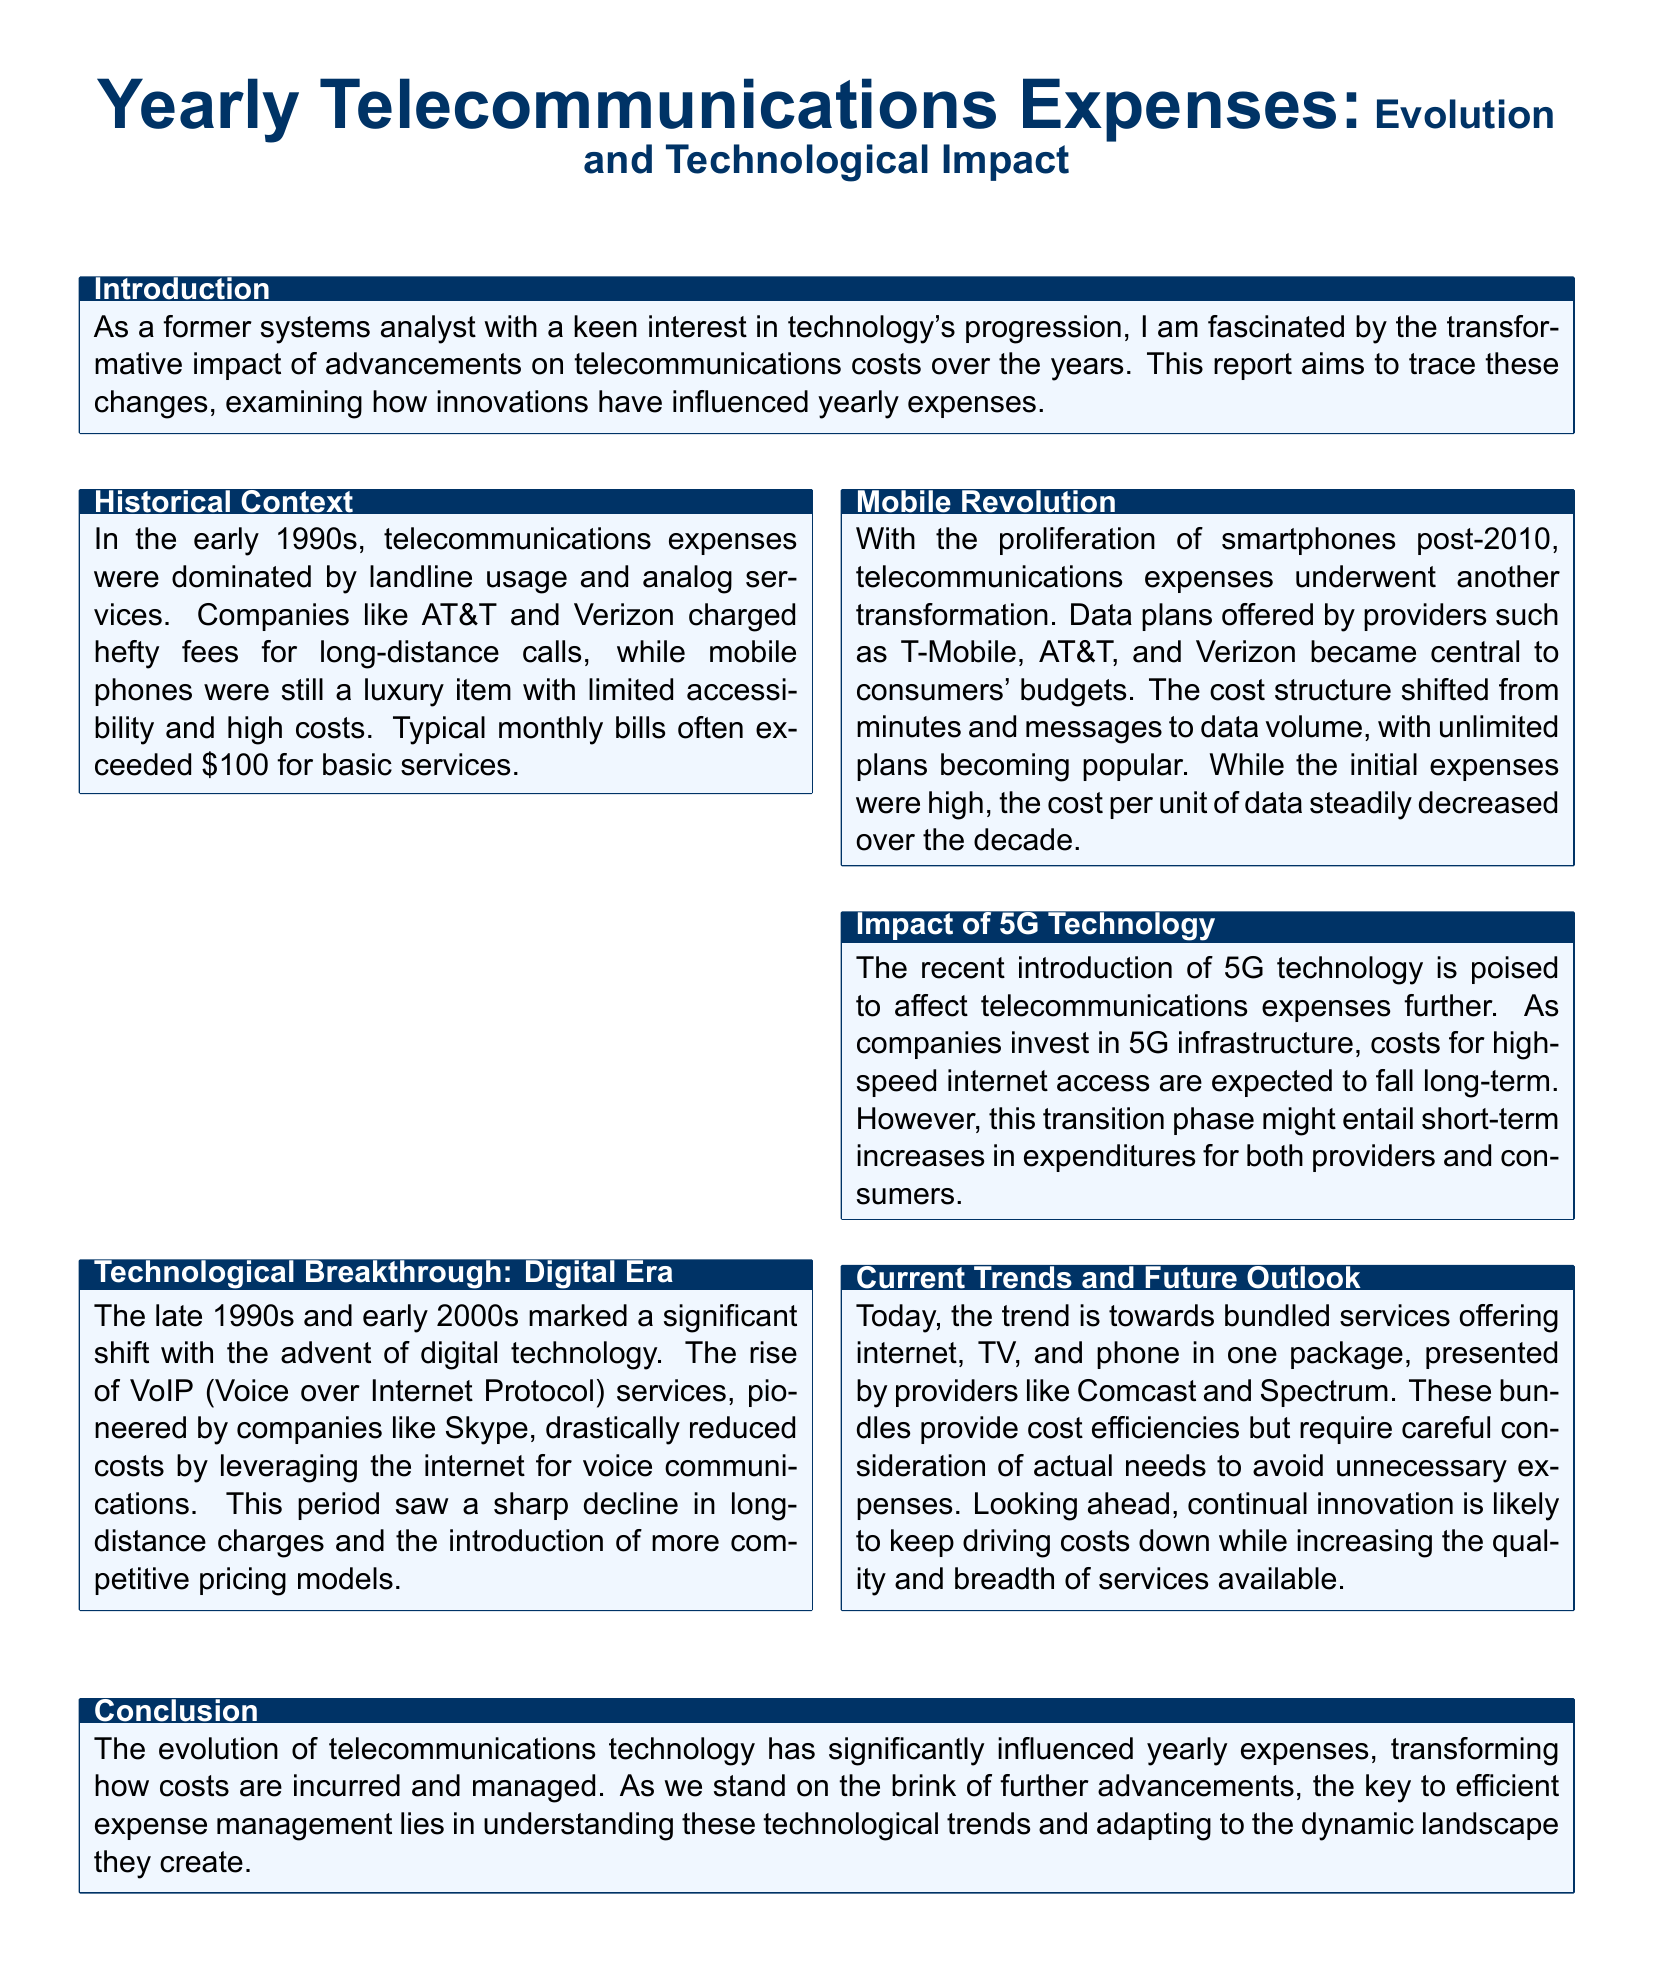What decade saw the introduction of VoIP services? The document states that the late 1990s and early 2000s marked the significant shift with the advent of VoIP services.
Answer: late 1990s and early 2000s What technology revolutionized telecommunications after 2010? The document mentions that the proliferation of smartphones post-2010 transformed telecommunications expenses.
Answer: smartphones Which companies are noted for charging high fees for long-distance calls? The document highlights companies like AT&T and Verizon as having charged hefty fees for long-distance calls in the early 1990s.
Answer: AT&T and Verizon What type of services are currently being bundled by providers? The document explains that the current trend is towards bundled services offering internet, TV, and phone.
Answer: internet, TV, and phone How did the cost per unit of data change over the decade after 2010? The document states that while the initial expenses were high, the cost per unit of data steadily decreased over the decade.
Answer: decreased What major technology is expected to lower telecommunications costs in the long-term? The document indicates that the introduction of 5G technology is expected to affect telecommunications expenses and lower costs long-term.
Answer: 5G technology What is the focus of the conclusion in the report? The conclusion emphasizes understanding technological trends for efficient expense management amidst evolving telecommunications.
Answer: efficient expense management What phrase describes the dominant service type in early 1990s telecommunications? The document describes telecommunications expenses in the early 1990s as being dominated by landline usage and analog services.
Answer: landline usage and analog services What is a potential short-term impact of transitioning to 5G technology? The document mentions that the transition phase to 5G might entail short-term increases in expenditures.
Answer: short-term increases 